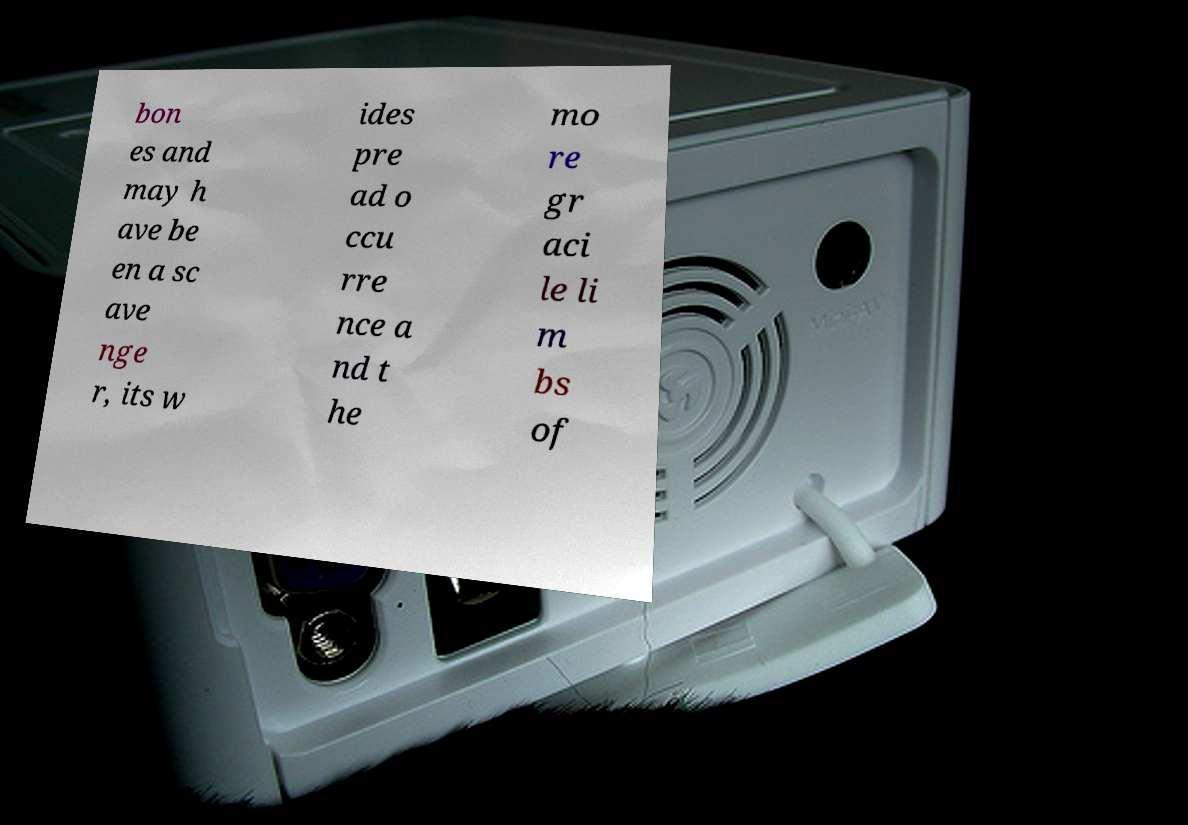I need the written content from this picture converted into text. Can you do that? bon es and may h ave be en a sc ave nge r, its w ides pre ad o ccu rre nce a nd t he mo re gr aci le li m bs of 